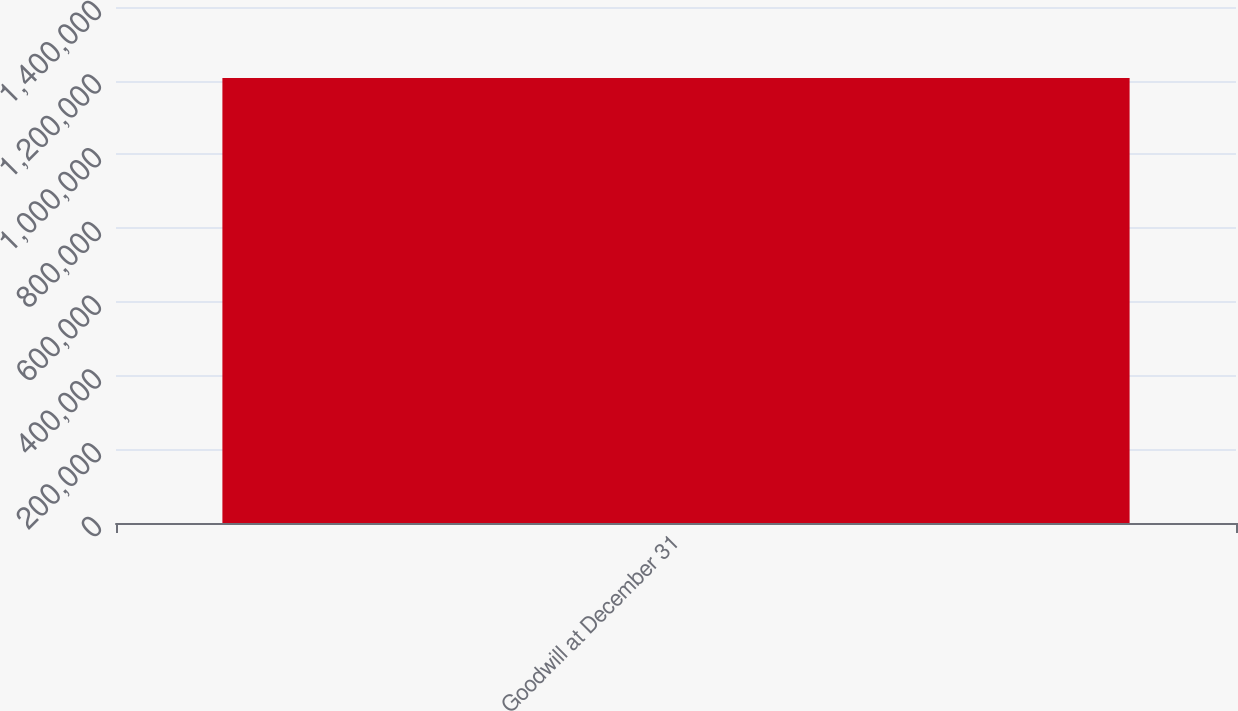<chart> <loc_0><loc_0><loc_500><loc_500><bar_chart><fcel>Goodwill at December 31<nl><fcel>1.20715e+06<nl></chart> 